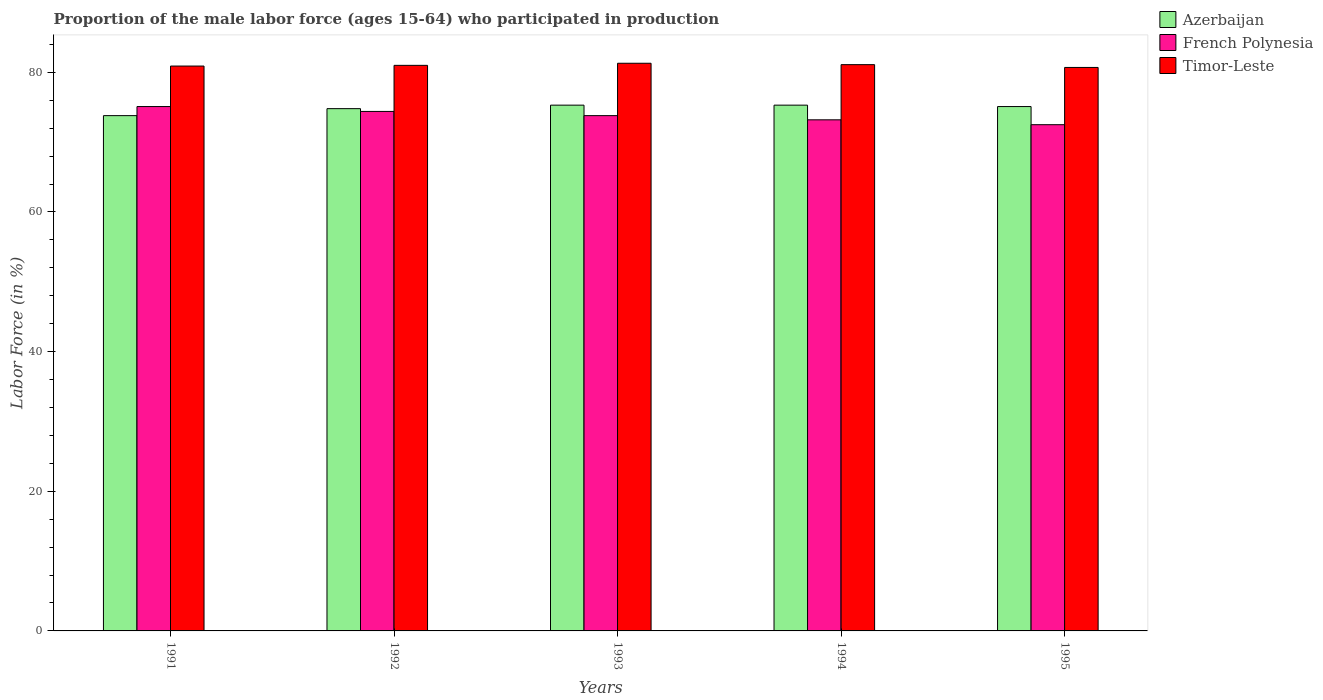How many groups of bars are there?
Make the answer very short. 5. Are the number of bars per tick equal to the number of legend labels?
Provide a succinct answer. Yes. Are the number of bars on each tick of the X-axis equal?
Provide a succinct answer. Yes. How many bars are there on the 5th tick from the left?
Offer a terse response. 3. What is the proportion of the male labor force who participated in production in French Polynesia in 1995?
Give a very brief answer. 72.5. Across all years, what is the maximum proportion of the male labor force who participated in production in French Polynesia?
Give a very brief answer. 75.1. Across all years, what is the minimum proportion of the male labor force who participated in production in Timor-Leste?
Provide a short and direct response. 80.7. What is the total proportion of the male labor force who participated in production in French Polynesia in the graph?
Provide a short and direct response. 369. What is the difference between the proportion of the male labor force who participated in production in Timor-Leste in 1992 and that in 1995?
Offer a terse response. 0.3. What is the difference between the proportion of the male labor force who participated in production in Azerbaijan in 1993 and the proportion of the male labor force who participated in production in Timor-Leste in 1991?
Offer a very short reply. -5.6. What is the average proportion of the male labor force who participated in production in Azerbaijan per year?
Your answer should be very brief. 74.86. In the year 1995, what is the difference between the proportion of the male labor force who participated in production in Azerbaijan and proportion of the male labor force who participated in production in Timor-Leste?
Your answer should be compact. -5.6. What is the ratio of the proportion of the male labor force who participated in production in Timor-Leste in 1992 to that in 1994?
Ensure brevity in your answer.  1. What is the difference between the highest and the second highest proportion of the male labor force who participated in production in Timor-Leste?
Your answer should be compact. 0.2. What is the difference between the highest and the lowest proportion of the male labor force who participated in production in French Polynesia?
Keep it short and to the point. 2.6. In how many years, is the proportion of the male labor force who participated in production in French Polynesia greater than the average proportion of the male labor force who participated in production in French Polynesia taken over all years?
Keep it short and to the point. 3. Is the sum of the proportion of the male labor force who participated in production in French Polynesia in 1992 and 1993 greater than the maximum proportion of the male labor force who participated in production in Azerbaijan across all years?
Your response must be concise. Yes. What does the 2nd bar from the left in 1992 represents?
Provide a succinct answer. French Polynesia. What does the 2nd bar from the right in 1995 represents?
Your answer should be very brief. French Polynesia. What is the difference between two consecutive major ticks on the Y-axis?
Your answer should be very brief. 20. Are the values on the major ticks of Y-axis written in scientific E-notation?
Your answer should be compact. No. How many legend labels are there?
Your response must be concise. 3. How are the legend labels stacked?
Your answer should be compact. Vertical. What is the title of the graph?
Make the answer very short. Proportion of the male labor force (ages 15-64) who participated in production. What is the Labor Force (in %) of Azerbaijan in 1991?
Your response must be concise. 73.8. What is the Labor Force (in %) of French Polynesia in 1991?
Offer a very short reply. 75.1. What is the Labor Force (in %) of Timor-Leste in 1991?
Your answer should be compact. 80.9. What is the Labor Force (in %) in Azerbaijan in 1992?
Make the answer very short. 74.8. What is the Labor Force (in %) of French Polynesia in 1992?
Make the answer very short. 74.4. What is the Labor Force (in %) in Timor-Leste in 1992?
Make the answer very short. 81. What is the Labor Force (in %) of Azerbaijan in 1993?
Your response must be concise. 75.3. What is the Labor Force (in %) in French Polynesia in 1993?
Provide a succinct answer. 73.8. What is the Labor Force (in %) of Timor-Leste in 1993?
Keep it short and to the point. 81.3. What is the Labor Force (in %) in Azerbaijan in 1994?
Keep it short and to the point. 75.3. What is the Labor Force (in %) of French Polynesia in 1994?
Offer a very short reply. 73.2. What is the Labor Force (in %) in Timor-Leste in 1994?
Offer a very short reply. 81.1. What is the Labor Force (in %) of Azerbaijan in 1995?
Your response must be concise. 75.1. What is the Labor Force (in %) of French Polynesia in 1995?
Provide a succinct answer. 72.5. What is the Labor Force (in %) in Timor-Leste in 1995?
Your answer should be compact. 80.7. Across all years, what is the maximum Labor Force (in %) in Azerbaijan?
Your response must be concise. 75.3. Across all years, what is the maximum Labor Force (in %) in French Polynesia?
Ensure brevity in your answer.  75.1. Across all years, what is the maximum Labor Force (in %) in Timor-Leste?
Ensure brevity in your answer.  81.3. Across all years, what is the minimum Labor Force (in %) of Azerbaijan?
Provide a short and direct response. 73.8. Across all years, what is the minimum Labor Force (in %) of French Polynesia?
Provide a short and direct response. 72.5. Across all years, what is the minimum Labor Force (in %) in Timor-Leste?
Your answer should be very brief. 80.7. What is the total Labor Force (in %) in Azerbaijan in the graph?
Offer a very short reply. 374.3. What is the total Labor Force (in %) of French Polynesia in the graph?
Ensure brevity in your answer.  369. What is the total Labor Force (in %) in Timor-Leste in the graph?
Keep it short and to the point. 405. What is the difference between the Labor Force (in %) of French Polynesia in 1991 and that in 1992?
Your response must be concise. 0.7. What is the difference between the Labor Force (in %) of Azerbaijan in 1991 and that in 1993?
Offer a terse response. -1.5. What is the difference between the Labor Force (in %) of French Polynesia in 1991 and that in 1993?
Your response must be concise. 1.3. What is the difference between the Labor Force (in %) of Timor-Leste in 1991 and that in 1994?
Offer a terse response. -0.2. What is the difference between the Labor Force (in %) in French Polynesia in 1991 and that in 1995?
Offer a very short reply. 2.6. What is the difference between the Labor Force (in %) in Azerbaijan in 1992 and that in 1994?
Offer a terse response. -0.5. What is the difference between the Labor Force (in %) in Timor-Leste in 1992 and that in 1995?
Keep it short and to the point. 0.3. What is the difference between the Labor Force (in %) of Timor-Leste in 1993 and that in 1994?
Provide a succinct answer. 0.2. What is the difference between the Labor Force (in %) of French Polynesia in 1993 and that in 1995?
Your response must be concise. 1.3. What is the difference between the Labor Force (in %) in Azerbaijan in 1994 and that in 1995?
Give a very brief answer. 0.2. What is the difference between the Labor Force (in %) in French Polynesia in 1994 and that in 1995?
Give a very brief answer. 0.7. What is the difference between the Labor Force (in %) in French Polynesia in 1991 and the Labor Force (in %) in Timor-Leste in 1992?
Your response must be concise. -5.9. What is the difference between the Labor Force (in %) in Azerbaijan in 1991 and the Labor Force (in %) in French Polynesia in 1993?
Provide a succinct answer. 0. What is the difference between the Labor Force (in %) in Azerbaijan in 1991 and the Labor Force (in %) in Timor-Leste in 1994?
Offer a very short reply. -7.3. What is the difference between the Labor Force (in %) of French Polynesia in 1991 and the Labor Force (in %) of Timor-Leste in 1994?
Offer a very short reply. -6. What is the difference between the Labor Force (in %) of Azerbaijan in 1991 and the Labor Force (in %) of French Polynesia in 1995?
Offer a terse response. 1.3. What is the difference between the Labor Force (in %) of Azerbaijan in 1991 and the Labor Force (in %) of Timor-Leste in 1995?
Offer a very short reply. -6.9. What is the difference between the Labor Force (in %) of French Polynesia in 1992 and the Labor Force (in %) of Timor-Leste in 1993?
Provide a short and direct response. -6.9. What is the difference between the Labor Force (in %) in Azerbaijan in 1992 and the Labor Force (in %) in French Polynesia in 1995?
Keep it short and to the point. 2.3. What is the difference between the Labor Force (in %) of French Polynesia in 1993 and the Labor Force (in %) of Timor-Leste in 1994?
Keep it short and to the point. -7.3. What is the difference between the Labor Force (in %) of Azerbaijan in 1993 and the Labor Force (in %) of French Polynesia in 1995?
Offer a very short reply. 2.8. What is the difference between the Labor Force (in %) of Azerbaijan in 1993 and the Labor Force (in %) of Timor-Leste in 1995?
Provide a succinct answer. -5.4. What is the difference between the Labor Force (in %) in French Polynesia in 1993 and the Labor Force (in %) in Timor-Leste in 1995?
Your answer should be very brief. -6.9. What is the difference between the Labor Force (in %) of Azerbaijan in 1994 and the Labor Force (in %) of Timor-Leste in 1995?
Make the answer very short. -5.4. What is the average Labor Force (in %) in Azerbaijan per year?
Your response must be concise. 74.86. What is the average Labor Force (in %) in French Polynesia per year?
Offer a terse response. 73.8. What is the average Labor Force (in %) of Timor-Leste per year?
Offer a very short reply. 81. In the year 1991, what is the difference between the Labor Force (in %) of Azerbaijan and Labor Force (in %) of Timor-Leste?
Keep it short and to the point. -7.1. In the year 1994, what is the difference between the Labor Force (in %) of Azerbaijan and Labor Force (in %) of French Polynesia?
Your answer should be compact. 2.1. In the year 1994, what is the difference between the Labor Force (in %) of Azerbaijan and Labor Force (in %) of Timor-Leste?
Ensure brevity in your answer.  -5.8. In the year 1994, what is the difference between the Labor Force (in %) in French Polynesia and Labor Force (in %) in Timor-Leste?
Provide a short and direct response. -7.9. What is the ratio of the Labor Force (in %) in Azerbaijan in 1991 to that in 1992?
Provide a succinct answer. 0.99. What is the ratio of the Labor Force (in %) in French Polynesia in 1991 to that in 1992?
Offer a very short reply. 1.01. What is the ratio of the Labor Force (in %) of Azerbaijan in 1991 to that in 1993?
Your answer should be very brief. 0.98. What is the ratio of the Labor Force (in %) of French Polynesia in 1991 to that in 1993?
Your answer should be very brief. 1.02. What is the ratio of the Labor Force (in %) in Azerbaijan in 1991 to that in 1994?
Ensure brevity in your answer.  0.98. What is the ratio of the Labor Force (in %) in Timor-Leste in 1991 to that in 1994?
Your answer should be compact. 1. What is the ratio of the Labor Force (in %) of Azerbaijan in 1991 to that in 1995?
Offer a very short reply. 0.98. What is the ratio of the Labor Force (in %) of French Polynesia in 1991 to that in 1995?
Provide a short and direct response. 1.04. What is the ratio of the Labor Force (in %) in Azerbaijan in 1992 to that in 1993?
Your answer should be compact. 0.99. What is the ratio of the Labor Force (in %) of French Polynesia in 1992 to that in 1993?
Provide a short and direct response. 1.01. What is the ratio of the Labor Force (in %) in Timor-Leste in 1992 to that in 1993?
Your response must be concise. 1. What is the ratio of the Labor Force (in %) in Azerbaijan in 1992 to that in 1994?
Give a very brief answer. 0.99. What is the ratio of the Labor Force (in %) of French Polynesia in 1992 to that in 1994?
Make the answer very short. 1.02. What is the ratio of the Labor Force (in %) of Azerbaijan in 1992 to that in 1995?
Offer a terse response. 1. What is the ratio of the Labor Force (in %) in French Polynesia in 1992 to that in 1995?
Offer a terse response. 1.03. What is the ratio of the Labor Force (in %) in French Polynesia in 1993 to that in 1994?
Keep it short and to the point. 1.01. What is the ratio of the Labor Force (in %) in Azerbaijan in 1993 to that in 1995?
Ensure brevity in your answer.  1. What is the ratio of the Labor Force (in %) of French Polynesia in 1993 to that in 1995?
Your answer should be very brief. 1.02. What is the ratio of the Labor Force (in %) in Timor-Leste in 1993 to that in 1995?
Provide a short and direct response. 1.01. What is the ratio of the Labor Force (in %) in French Polynesia in 1994 to that in 1995?
Provide a short and direct response. 1.01. What is the ratio of the Labor Force (in %) in Timor-Leste in 1994 to that in 1995?
Keep it short and to the point. 1. What is the difference between the highest and the lowest Labor Force (in %) of French Polynesia?
Provide a short and direct response. 2.6. What is the difference between the highest and the lowest Labor Force (in %) of Timor-Leste?
Keep it short and to the point. 0.6. 